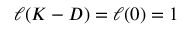Convert formula to latex. <formula><loc_0><loc_0><loc_500><loc_500>\ell ( K - D ) = \ell ( 0 ) = 1</formula> 